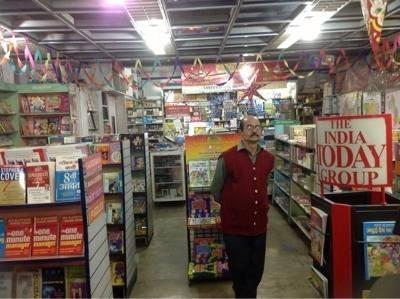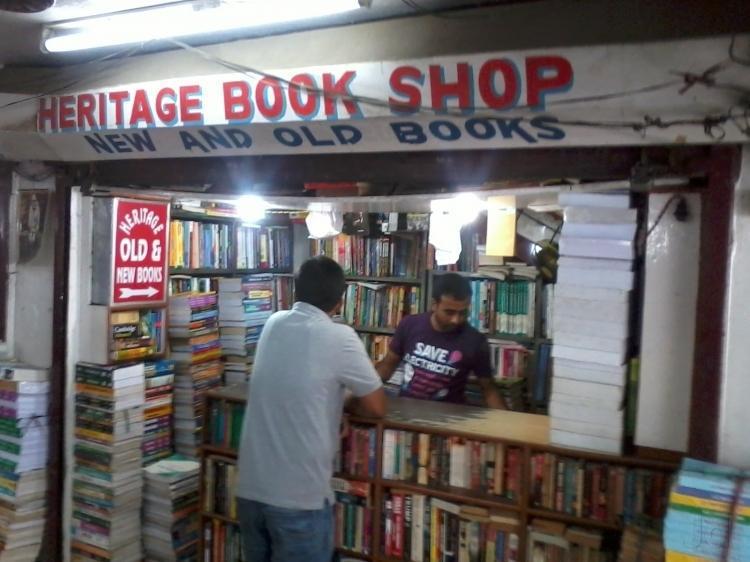The first image is the image on the left, the second image is the image on the right. For the images displayed, is the sentence "Each of the images features the outside of a store." factually correct? Answer yes or no. No. The first image is the image on the left, the second image is the image on the right. For the images displayed, is the sentence "An image shows one man in a buttoned vest standing in the front area of a book store." factually correct? Answer yes or no. Yes. 